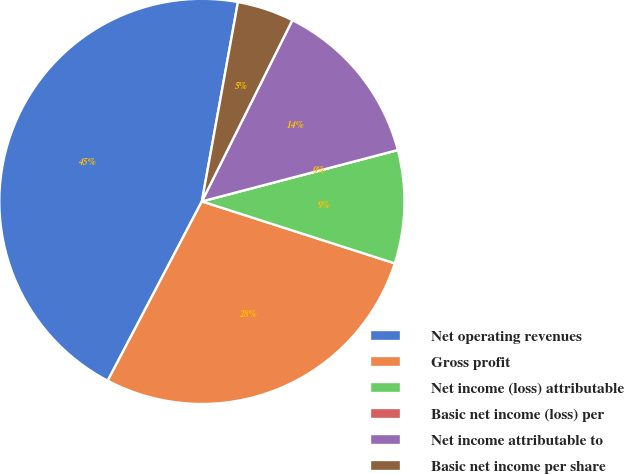Convert chart. <chart><loc_0><loc_0><loc_500><loc_500><pie_chart><fcel>Net operating revenues<fcel>Gross profit<fcel>Net income (loss) attributable<fcel>Basic net income (loss) per<fcel>Net income attributable to<fcel>Basic net income per share<nl><fcel>45.15%<fcel>27.75%<fcel>9.03%<fcel>0.0%<fcel>13.55%<fcel>4.52%<nl></chart> 